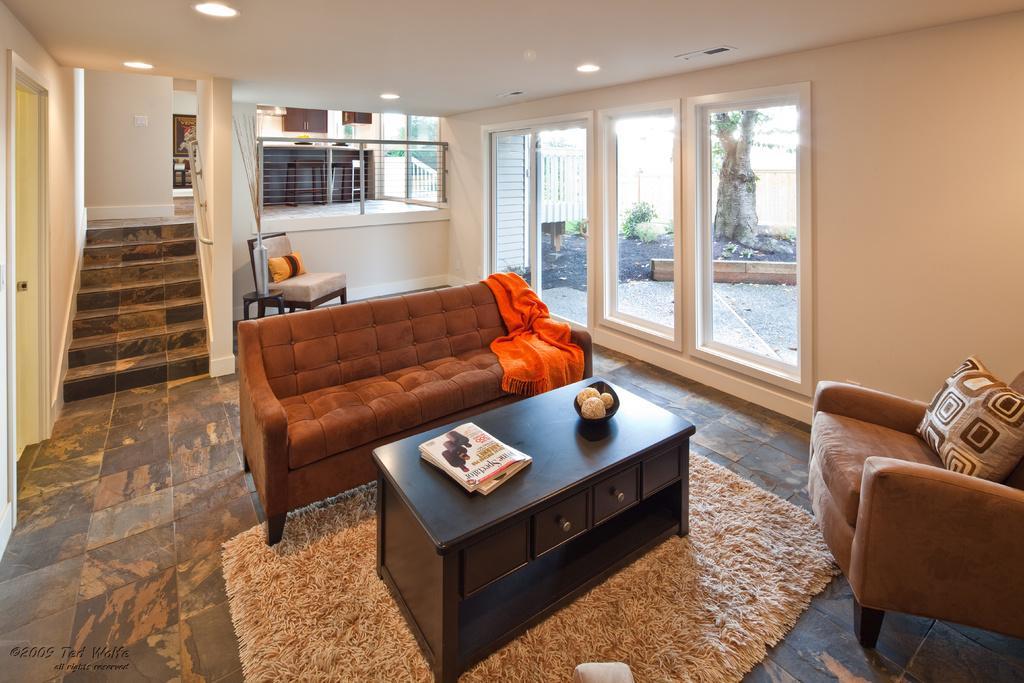Describe this image in one or two sentences. In this picture there are books and a bowl on the table. There is a sofa and white cloth on the table. There is a chair and a pillow. There is a vase. There are some lights on the roof. There is a frame on the wall, cupboard and a plant and tree at the background. There is a carpet. 